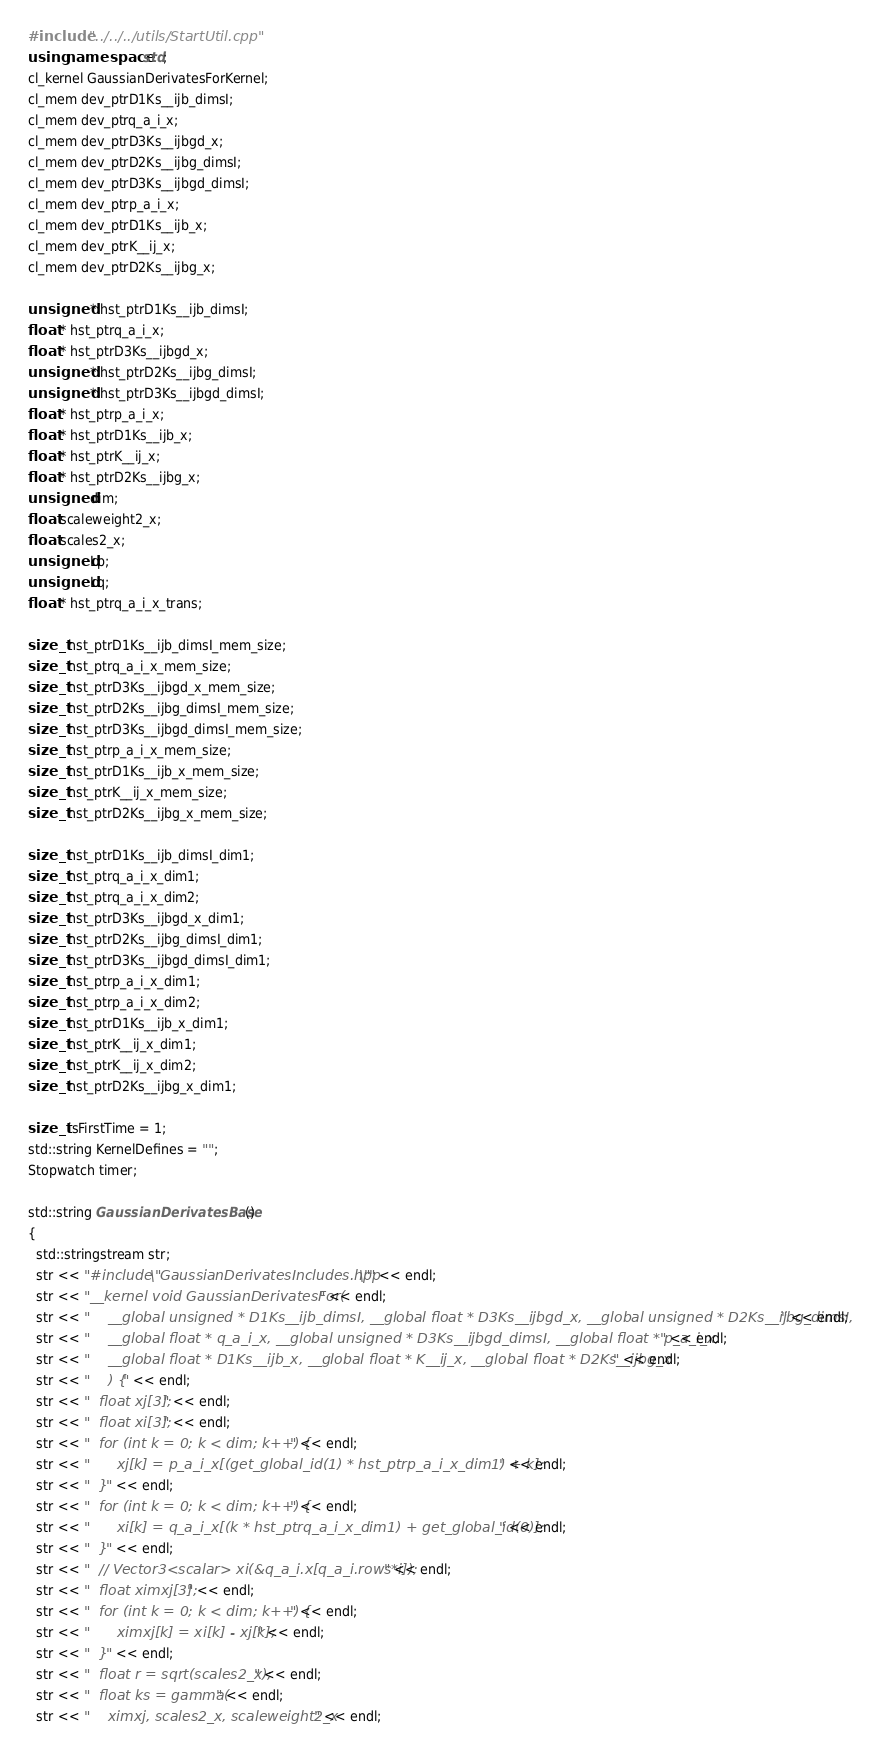Convert code to text. <code><loc_0><loc_0><loc_500><loc_500><_C++_>#include "../../../utils/StartUtil.cpp"
using namespace std;
cl_kernel GaussianDerivatesForKernel;
cl_mem dev_ptrD1Ks__ijb_dimsI;
cl_mem dev_ptrq_a_i_x;
cl_mem dev_ptrD3Ks__ijbgd_x;
cl_mem dev_ptrD2Ks__ijbg_dimsI;
cl_mem dev_ptrD3Ks__ijbgd_dimsI;
cl_mem dev_ptrp_a_i_x;
cl_mem dev_ptrD1Ks__ijb_x;
cl_mem dev_ptrK__ij_x;
cl_mem dev_ptrD2Ks__ijbg_x;

unsigned * hst_ptrD1Ks__ijb_dimsI;
float * hst_ptrq_a_i_x;
float * hst_ptrD3Ks__ijbgd_x;
unsigned * hst_ptrD2Ks__ijbg_dimsI;
unsigned * hst_ptrD3Ks__ijbgd_dimsI;
float * hst_ptrp_a_i_x;
float * hst_ptrD1Ks__ijb_x;
float * hst_ptrK__ij_x;
float * hst_ptrD2Ks__ijbg_x;
unsigned dim;
float scaleweight2_x;
float scales2_x;
unsigned Lp;
unsigned Lq;
float * hst_ptrq_a_i_x_trans;

size_t hst_ptrD1Ks__ijb_dimsI_mem_size;
size_t hst_ptrq_a_i_x_mem_size;
size_t hst_ptrD3Ks__ijbgd_x_mem_size;
size_t hst_ptrD2Ks__ijbg_dimsI_mem_size;
size_t hst_ptrD3Ks__ijbgd_dimsI_mem_size;
size_t hst_ptrp_a_i_x_mem_size;
size_t hst_ptrD1Ks__ijb_x_mem_size;
size_t hst_ptrK__ij_x_mem_size;
size_t hst_ptrD2Ks__ijbg_x_mem_size;

size_t hst_ptrD1Ks__ijb_dimsI_dim1;
size_t hst_ptrq_a_i_x_dim1;
size_t hst_ptrq_a_i_x_dim2;
size_t hst_ptrD3Ks__ijbgd_x_dim1;
size_t hst_ptrD2Ks__ijbg_dimsI_dim1;
size_t hst_ptrD3Ks__ijbgd_dimsI_dim1;
size_t hst_ptrp_a_i_x_dim1;
size_t hst_ptrp_a_i_x_dim2;
size_t hst_ptrD1Ks__ijb_x_dim1;
size_t hst_ptrK__ij_x_dim1;
size_t hst_ptrK__ij_x_dim2;
size_t hst_ptrD2Ks__ijbg_x_dim1;

size_t isFirstTime = 1;
std::string KernelDefines = "";
Stopwatch timer;

std::string GaussianDerivatesBase()
{
  std::stringstream str;
  str << "#include \"GaussianDerivatesIncludes.hpp\"" << endl;
  str << "__kernel void GaussianDerivatesFor(" << endl;
  str << "	__global unsigned * D1Ks__ijb_dimsI, __global float * D3Ks__ijbgd_x, __global unsigned * D2Ks__ijbg_dimsI, " << endl;
  str << "	__global float * q_a_i_x, __global unsigned * D3Ks__ijbgd_dimsI, __global float * p_a_i_x, " << endl;
  str << "	__global float * D1Ks__ijb_x, __global float * K__ij_x, __global float * D2Ks__ijbg_x" << endl;
  str << "	) {" << endl;
  str << "  float xj[3];" << endl;
  str << "  float xi[3];" << endl;
  str << "  for (int k = 0; k < dim; k++) {" << endl;
  str << "      xj[k] = p_a_i_x[(get_global_id(1) * hst_ptrp_a_i_x_dim1) + k];" << endl;
  str << "  }" << endl;
  str << "  for (int k = 0; k < dim; k++) {" << endl;
  str << "      xi[k] = q_a_i_x[(k * hst_ptrq_a_i_x_dim1) + get_global_id(0)];" << endl;
  str << "  }" << endl;
  str << "  // Vector3<scalar> xi(&q_a_i.x[q_a_i.rows*i]);" << endl;
  str << "  float ximxj[3];" << endl;
  str << "  for (int k = 0; k < dim; k++) {" << endl;
  str << "      ximxj[k] = xi[k] - xj[k];" << endl;
  str << "  }" << endl;
  str << "  float r = sqrt(scales2_x);" << endl;
  str << "  float ks = gamma(" << endl;
  str << "	ximxj, scales2_x, scaleweight2_x" << endl;</code> 